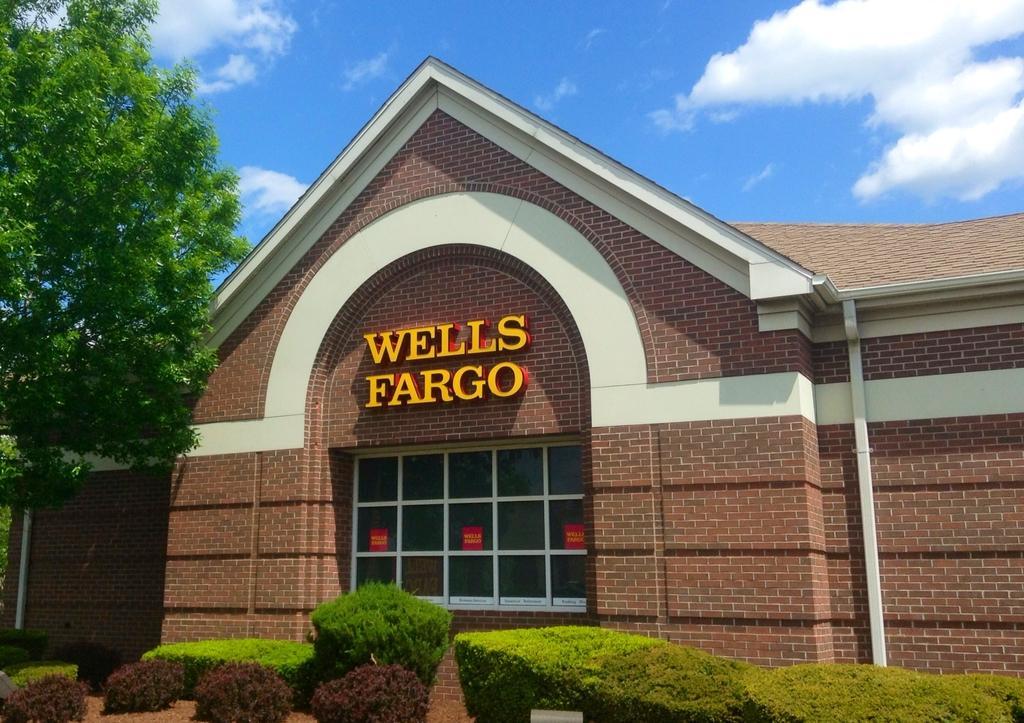Could you give a brief overview of what you see in this image? In this picture we can see a building with a window and a name board. In front of the building, there are plants. On the left side of the image, there are trees. At the top of the image, there is the sky. 